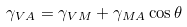<formula> <loc_0><loc_0><loc_500><loc_500>\gamma _ { V A } = \gamma _ { V M } + \gamma _ { M A } \cos \theta</formula> 